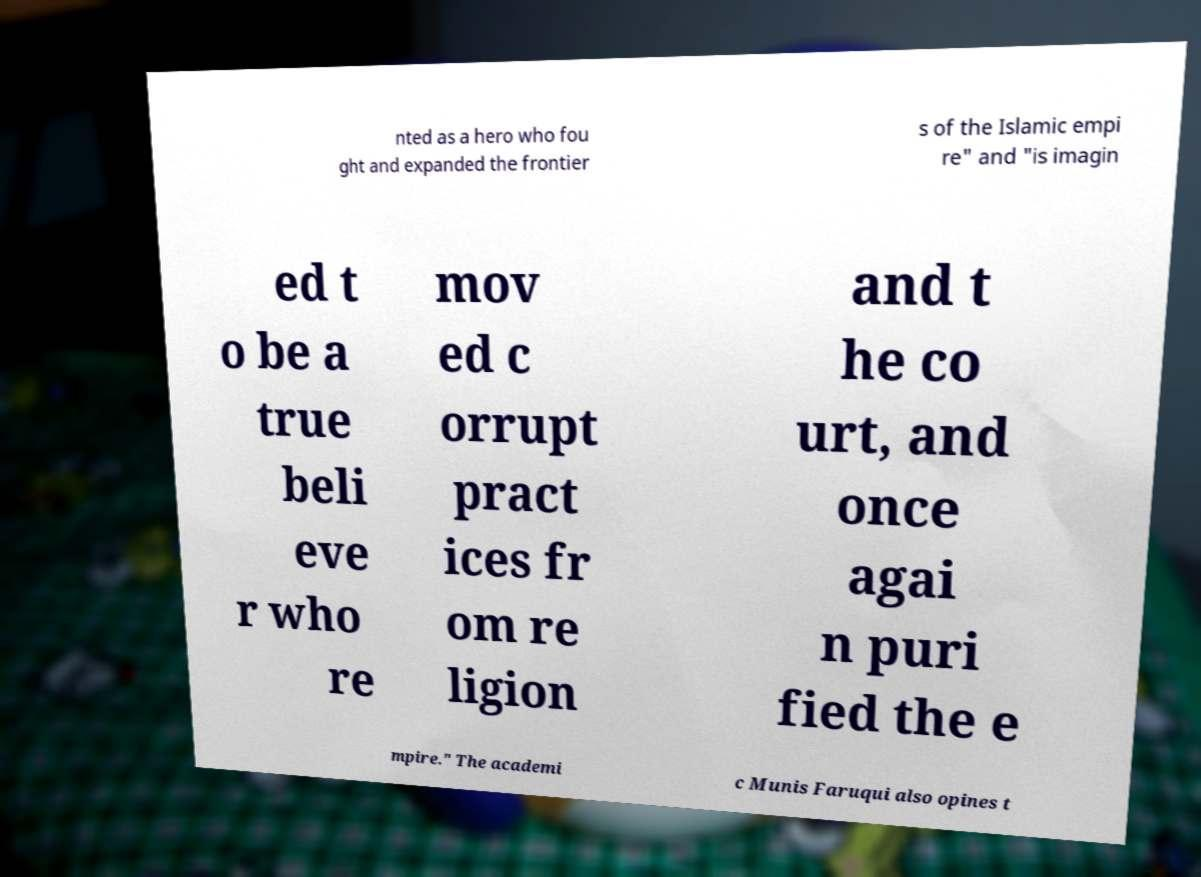Could you extract and type out the text from this image? nted as a hero who fou ght and expanded the frontier s of the Islamic empi re" and "is imagin ed t o be a true beli eve r who re mov ed c orrupt pract ices fr om re ligion and t he co urt, and once agai n puri fied the e mpire." The academi c Munis Faruqui also opines t 